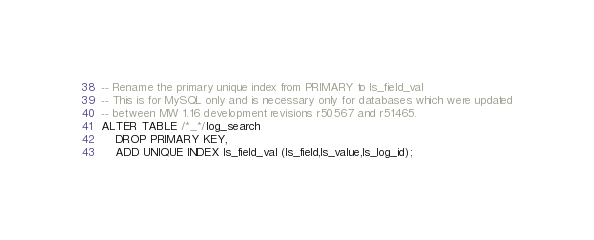<code> <loc_0><loc_0><loc_500><loc_500><_SQL_>-- Rename the primary unique index from PRIMARY to ls_field_val
-- This is for MySQL only and is necessary only for databases which were updated
-- between MW 1.16 development revisions r50567 and r51465.
ALTER TABLE /*_*/log_search
	DROP PRIMARY KEY,
	ADD UNIQUE INDEX ls_field_val (ls_field,ls_value,ls_log_id);

</code> 